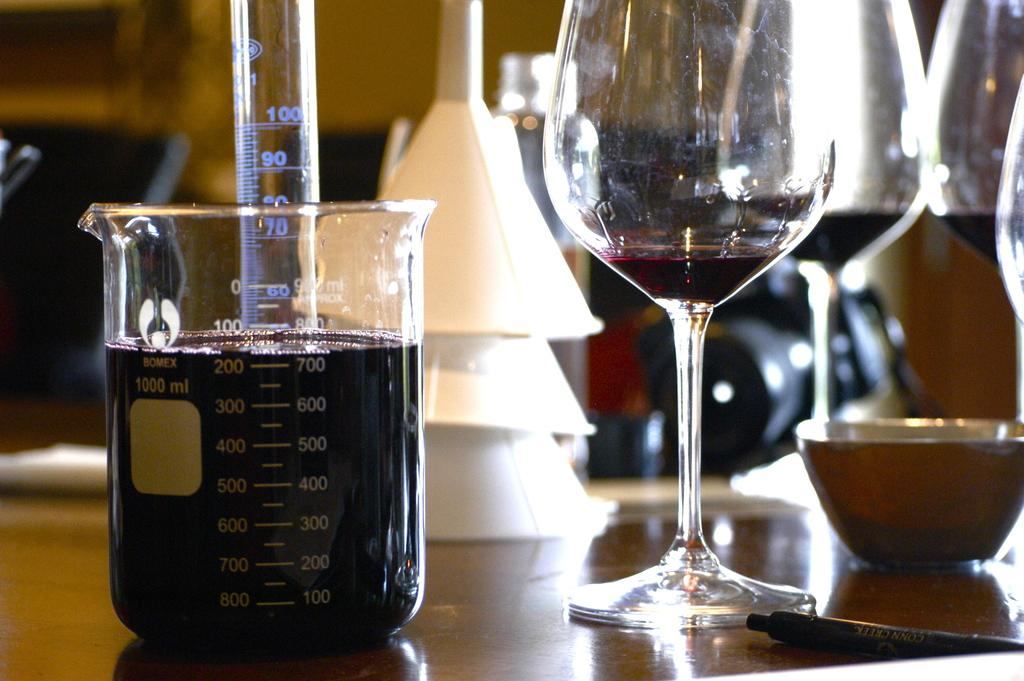Provide a one-sentence caption for the provided image. A glass of wine next to a measuring cup with digits like 400 and 500 listed. 